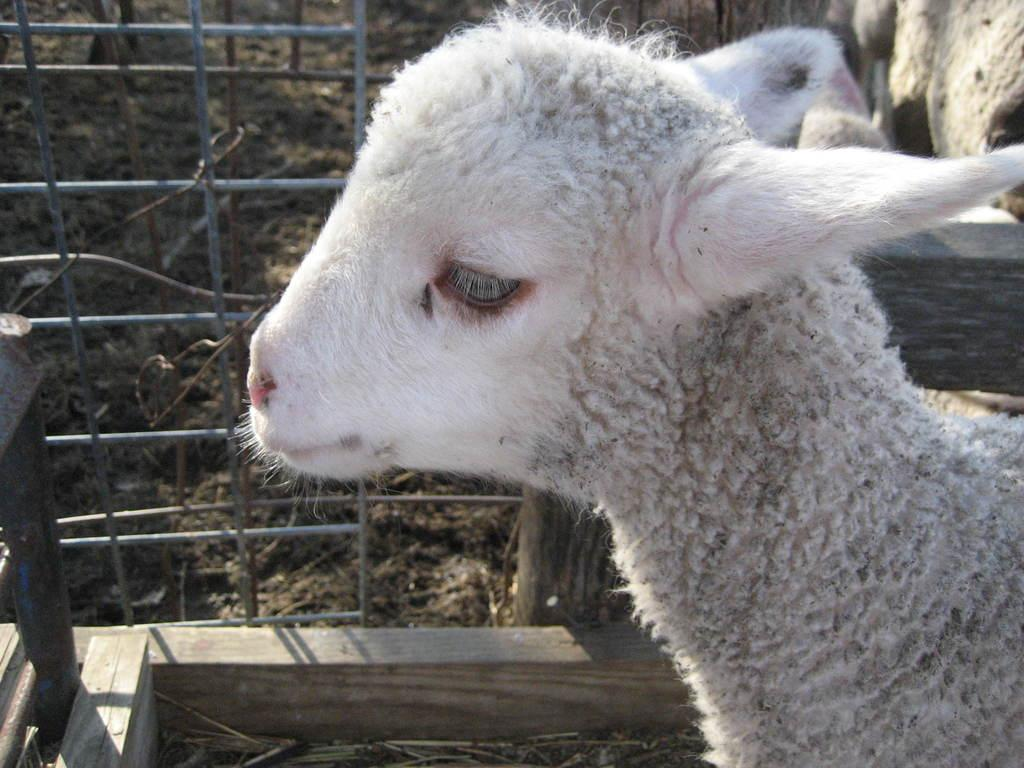What type of animal is in the image? There is an animal in the image, but its specific type is not mentioned in the facts. What color is the animal in the image? The animal is white in color. What is present in the image that might be used for enclosing or separating areas? There is fencing in the image. What type of terrain or surface is visible in the image? There is mud in the image. How many giants are visible in the image? There are no giants present in the image. What type of pet is shown interacting with the animal in the image? There is no pet present in the image; only the animal and the fencing are visible. 